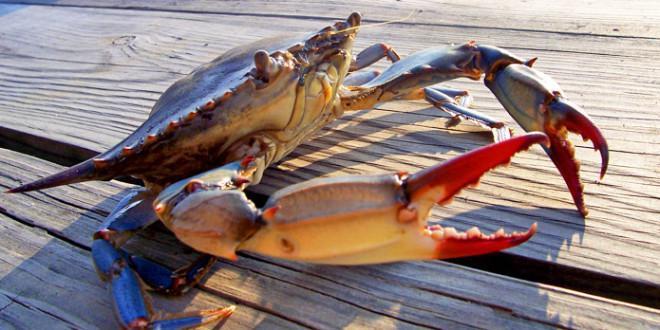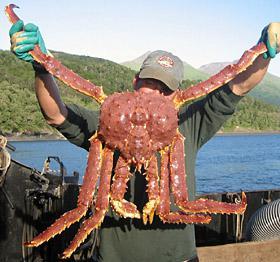The first image is the image on the left, the second image is the image on the right. For the images shown, is this caption "No image contains more than two crabs, and no image features crabs that are prepared for eating." true? Answer yes or no. Yes. The first image is the image on the left, the second image is the image on the right. For the images displayed, is the sentence "There are two crabs next to each other." factually correct? Answer yes or no. No. 